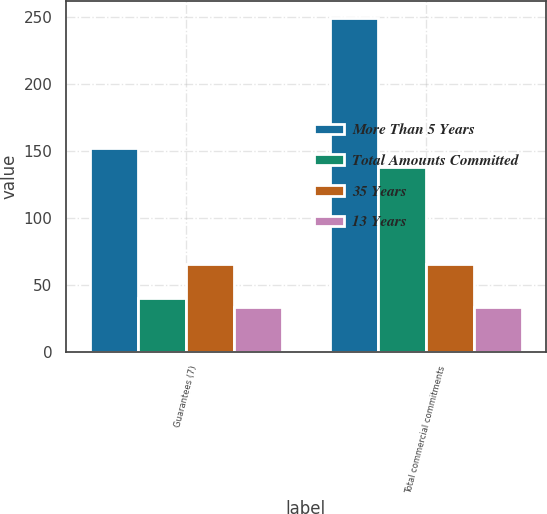Convert chart. <chart><loc_0><loc_0><loc_500><loc_500><stacked_bar_chart><ecel><fcel>Guarantees (7)<fcel>Total commercial commitments<nl><fcel>More Than 5 Years<fcel>151.6<fcel>249.1<nl><fcel>Total Amounts Committed<fcel>40.2<fcel>137.7<nl><fcel>35 Years<fcel>65<fcel>65<nl><fcel>13 Years<fcel>33.3<fcel>33.3<nl></chart> 